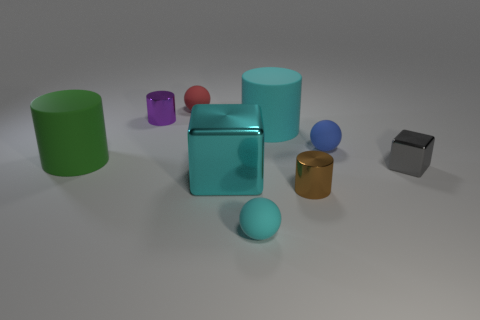There is a tiny gray metallic cube; are there any small purple cylinders to the right of it?
Give a very brief answer. No. Is the size of the gray cube the same as the cyan rubber thing in front of the blue matte sphere?
Offer a terse response. Yes. How many other things are there of the same material as the cyan block?
Keep it short and to the point. 3. There is a rubber object that is on the right side of the large green matte cylinder and in front of the blue rubber ball; what is its shape?
Give a very brief answer. Sphere. Does the shiny thing that is on the right side of the small brown shiny cylinder have the same size as the cyan thing behind the green matte cylinder?
Give a very brief answer. No. There is a purple object that is the same material as the large cyan cube; what is its shape?
Keep it short and to the point. Cylinder. Is there anything else that has the same shape as the small cyan rubber object?
Offer a terse response. Yes. The rubber cylinder that is to the right of the big cyan thing in front of the large rubber cylinder left of the large cyan cube is what color?
Make the answer very short. Cyan. Is the number of metal things to the right of the small cyan sphere less than the number of brown objects behind the blue object?
Provide a short and direct response. No. Is the small purple thing the same shape as the tiny brown shiny thing?
Provide a succinct answer. Yes. 